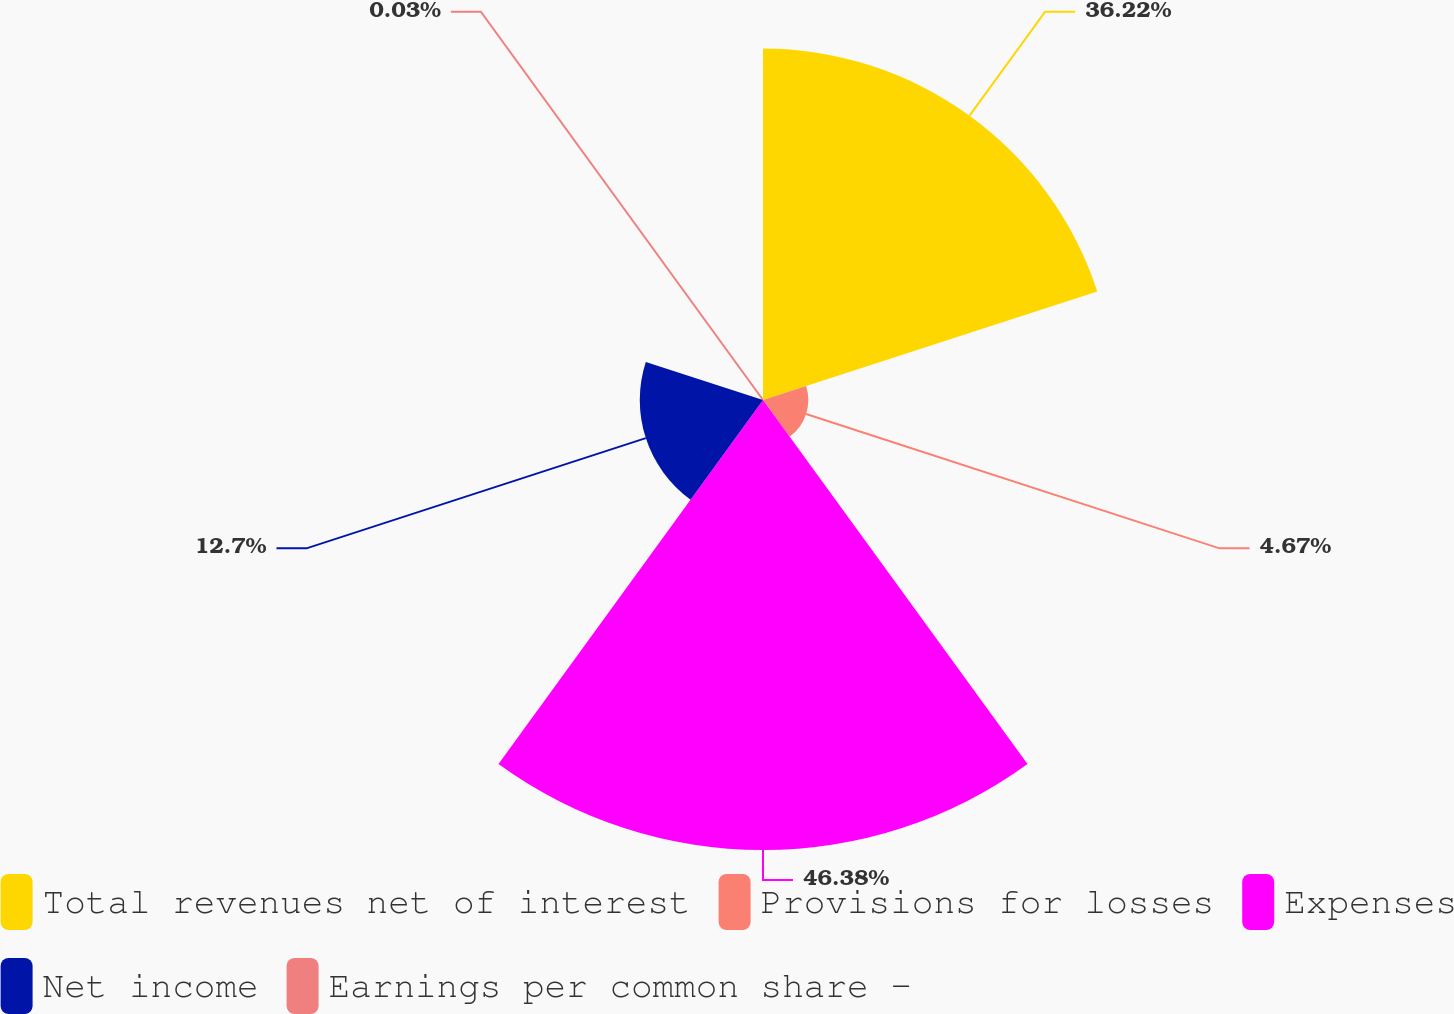Convert chart. <chart><loc_0><loc_0><loc_500><loc_500><pie_chart><fcel>Total revenues net of interest<fcel>Provisions for losses<fcel>Expenses<fcel>Net income<fcel>Earnings per common share -<nl><fcel>36.22%<fcel>4.67%<fcel>46.38%<fcel>12.7%<fcel>0.03%<nl></chart> 